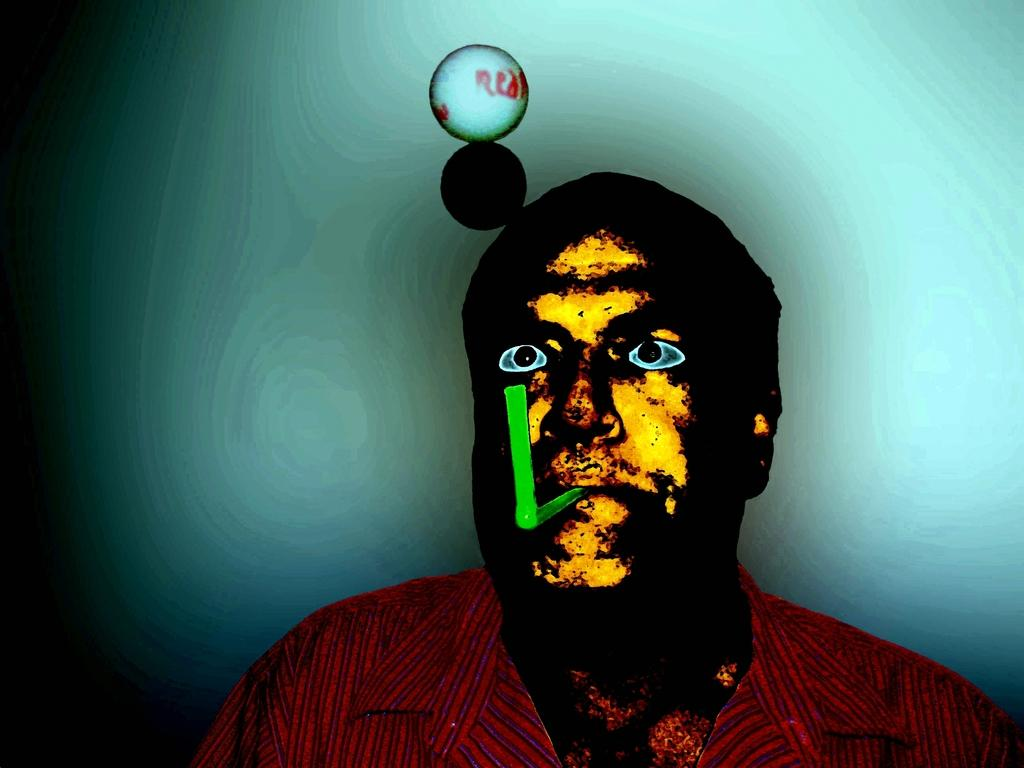What can be observed about the image itself? The image appears to be edited. Who is the main subject in the image? There is a man in the middle of the image. What is the man wearing? The man is wearing a shirt. What is in the man's mouth? There is a plastic thing in the man's mouth. What is the shape of the meal on the table in the image? There is no table or meal present in the image. What is the price of the item the man is holding in the image? The man is not holding any item in the image. 